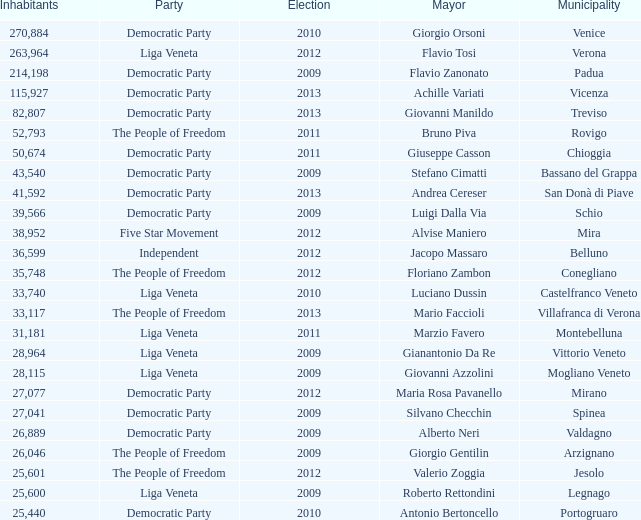How many inhabitants were part of the democratic party in a mayoral election for stefano cimatti before 2009? 0.0. 